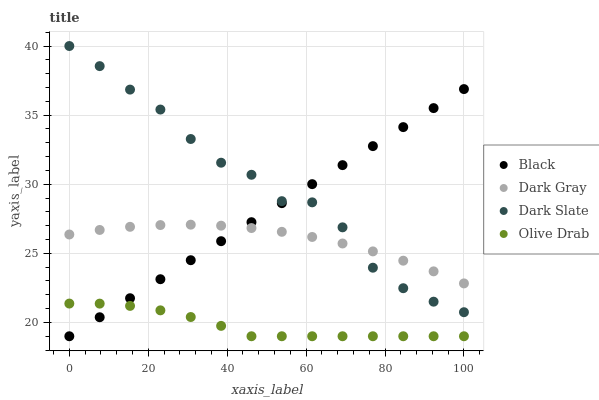Does Olive Drab have the minimum area under the curve?
Answer yes or no. Yes. Does Dark Slate have the maximum area under the curve?
Answer yes or no. Yes. Does Black have the minimum area under the curve?
Answer yes or no. No. Does Black have the maximum area under the curve?
Answer yes or no. No. Is Black the smoothest?
Answer yes or no. Yes. Is Dark Slate the roughest?
Answer yes or no. Yes. Is Dark Slate the smoothest?
Answer yes or no. No. Is Black the roughest?
Answer yes or no. No. Does Black have the lowest value?
Answer yes or no. Yes. Does Dark Slate have the lowest value?
Answer yes or no. No. Does Dark Slate have the highest value?
Answer yes or no. Yes. Does Black have the highest value?
Answer yes or no. No. Is Olive Drab less than Dark Gray?
Answer yes or no. Yes. Is Dark Gray greater than Olive Drab?
Answer yes or no. Yes. Does Black intersect Dark Gray?
Answer yes or no. Yes. Is Black less than Dark Gray?
Answer yes or no. No. Is Black greater than Dark Gray?
Answer yes or no. No. Does Olive Drab intersect Dark Gray?
Answer yes or no. No. 